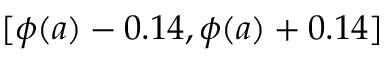<formula> <loc_0><loc_0><loc_500><loc_500>[ \phi ( a ) - 0 . 1 4 , \phi ( a ) + 0 . 1 4 ]</formula> 